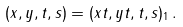Convert formula to latex. <formula><loc_0><loc_0><loc_500><loc_500>( x , y , t , s ) = ( x t , y t , t , s ) _ { 1 } \, .</formula> 